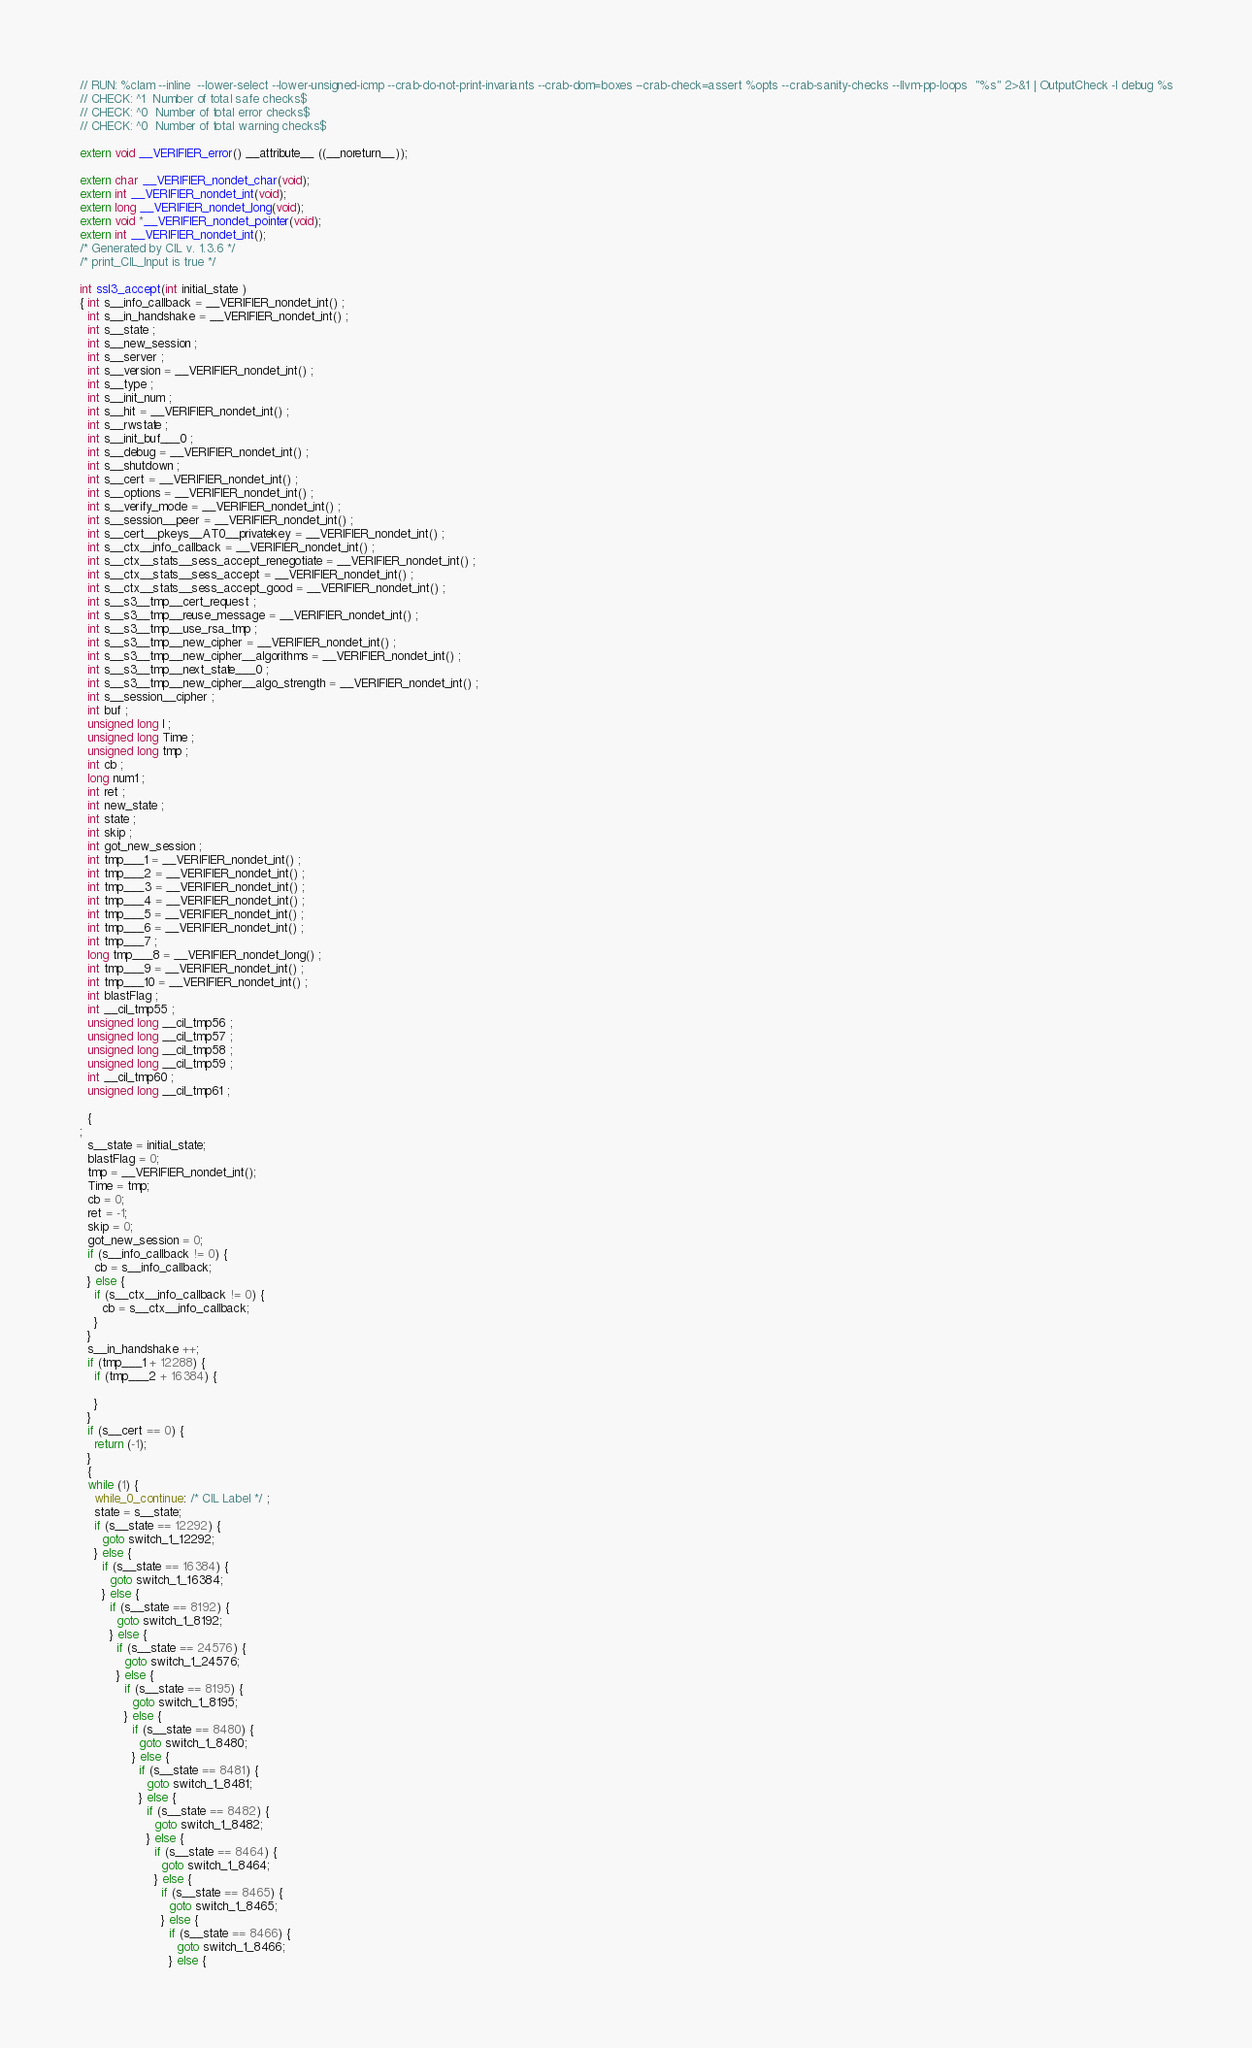Convert code to text. <code><loc_0><loc_0><loc_500><loc_500><_C_>// RUN: %clam --inline  --lower-select --lower-unsigned-icmp --crab-do-not-print-invariants --crab-dom=boxes --crab-check=assert %opts --crab-sanity-checks --llvm-pp-loops  "%s" 2>&1 | OutputCheck -l debug %s
// CHECK: ^1  Number of total safe checks$
// CHECK: ^0  Number of total error checks$
// CHECK: ^0  Number of total warning checks$

extern void __VERIFIER_error() __attribute__ ((__noreturn__));

extern char __VERIFIER_nondet_char(void);
extern int __VERIFIER_nondet_int(void);
extern long __VERIFIER_nondet_long(void);
extern void *__VERIFIER_nondet_pointer(void);
extern int __VERIFIER_nondet_int();
/* Generated by CIL v. 1.3.6 */
/* print_CIL_Input is true */

int ssl3_accept(int initial_state ) 
{ int s__info_callback = __VERIFIER_nondet_int() ;
  int s__in_handshake = __VERIFIER_nondet_int() ;
  int s__state ;
  int s__new_session ;
  int s__server ;
  int s__version = __VERIFIER_nondet_int() ;
  int s__type ;
  int s__init_num ;
  int s__hit = __VERIFIER_nondet_int() ;
  int s__rwstate ;
  int s__init_buf___0 ;
  int s__debug = __VERIFIER_nondet_int() ;
  int s__shutdown ;
  int s__cert = __VERIFIER_nondet_int() ;
  int s__options = __VERIFIER_nondet_int() ;
  int s__verify_mode = __VERIFIER_nondet_int() ;
  int s__session__peer = __VERIFIER_nondet_int() ;
  int s__cert__pkeys__AT0__privatekey = __VERIFIER_nondet_int() ;
  int s__ctx__info_callback = __VERIFIER_nondet_int() ;
  int s__ctx__stats__sess_accept_renegotiate = __VERIFIER_nondet_int() ;
  int s__ctx__stats__sess_accept = __VERIFIER_nondet_int() ;
  int s__ctx__stats__sess_accept_good = __VERIFIER_nondet_int() ;
  int s__s3__tmp__cert_request ;
  int s__s3__tmp__reuse_message = __VERIFIER_nondet_int() ;
  int s__s3__tmp__use_rsa_tmp ;
  int s__s3__tmp__new_cipher = __VERIFIER_nondet_int() ;
  int s__s3__tmp__new_cipher__algorithms = __VERIFIER_nondet_int() ;
  int s__s3__tmp__next_state___0 ;
  int s__s3__tmp__new_cipher__algo_strength = __VERIFIER_nondet_int() ;
  int s__session__cipher ;
  int buf ;
  unsigned long l ;
  unsigned long Time ;
  unsigned long tmp ;
  int cb ;
  long num1 ;
  int ret ;
  int new_state ;
  int state ;
  int skip ;
  int got_new_session ;
  int tmp___1 = __VERIFIER_nondet_int() ;
  int tmp___2 = __VERIFIER_nondet_int() ;
  int tmp___3 = __VERIFIER_nondet_int() ;
  int tmp___4 = __VERIFIER_nondet_int() ;
  int tmp___5 = __VERIFIER_nondet_int() ;
  int tmp___6 = __VERIFIER_nondet_int() ;
  int tmp___7 ;
  long tmp___8 = __VERIFIER_nondet_long() ;
  int tmp___9 = __VERIFIER_nondet_int() ;
  int tmp___10 = __VERIFIER_nondet_int() ;
  int blastFlag ;
  int __cil_tmp55 ;
  unsigned long __cil_tmp56 ;
  unsigned long __cil_tmp57 ;
  unsigned long __cil_tmp58 ;
  unsigned long __cil_tmp59 ;
  int __cil_tmp60 ;
  unsigned long __cil_tmp61 ;

  {
;
  s__state = initial_state;
  blastFlag = 0;
  tmp = __VERIFIER_nondet_int();
  Time = tmp;
  cb = 0;
  ret = -1;
  skip = 0;
  got_new_session = 0;
  if (s__info_callback != 0) {
    cb = s__info_callback;
  } else {
    if (s__ctx__info_callback != 0) {
      cb = s__ctx__info_callback;
    }
  }
  s__in_handshake ++;
  if (tmp___1 + 12288) {
    if (tmp___2 + 16384) {

    }
  }
  if (s__cert == 0) {
    return (-1);
  }
  {
  while (1) {
    while_0_continue: /* CIL Label */ ;
    state = s__state;
    if (s__state == 12292) {
      goto switch_1_12292;
    } else {
      if (s__state == 16384) {
        goto switch_1_16384;
      } else {
        if (s__state == 8192) {
          goto switch_1_8192;
        } else {
          if (s__state == 24576) {
            goto switch_1_24576;
          } else {
            if (s__state == 8195) {
              goto switch_1_8195;
            } else {
              if (s__state == 8480) {
                goto switch_1_8480;
              } else {
                if (s__state == 8481) {
                  goto switch_1_8481;
                } else {
                  if (s__state == 8482) {
                    goto switch_1_8482;
                  } else {
                    if (s__state == 8464) {
                      goto switch_1_8464;
                    } else {
                      if (s__state == 8465) {
                        goto switch_1_8465;
                      } else {
                        if (s__state == 8466) {
                          goto switch_1_8466;
                        } else {</code> 